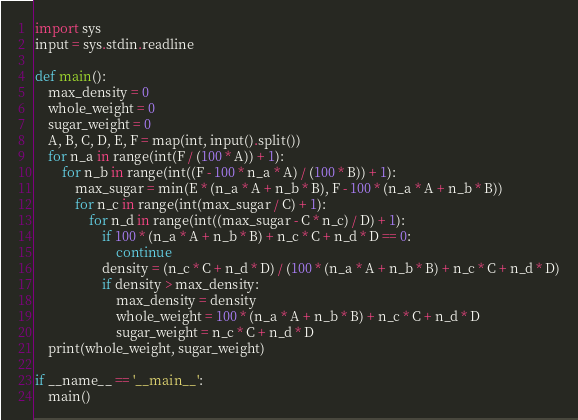<code> <loc_0><loc_0><loc_500><loc_500><_Python_>import sys
input = sys.stdin.readline

def main():
    max_density = 0
    whole_weight = 0
    sugar_weight = 0
    A, B, C, D, E, F = map(int, input().split())
    for n_a in range(int(F / (100 * A)) + 1):
        for n_b in range(int((F - 100 * n_a * A) / (100 * B)) + 1):
            max_sugar = min(E * (n_a * A + n_b * B), F - 100 * (n_a * A + n_b * B))
            for n_c in range(int(max_sugar / C) + 1):
                for n_d in range(int((max_sugar - C * n_c) / D) + 1):
                    if 100 * (n_a * A + n_b * B) + n_c * C + n_d * D == 0:
                        continue
                    density = (n_c * C + n_d * D) / (100 * (n_a * A + n_b * B) + n_c * C + n_d * D)
                    if density > max_density:
                        max_density = density
                        whole_weight = 100 * (n_a * A + n_b * B) + n_c * C + n_d * D
                        sugar_weight = n_c * C + n_d * D
    print(whole_weight, sugar_weight)

if __name__ == '__main__':
    main()</code> 